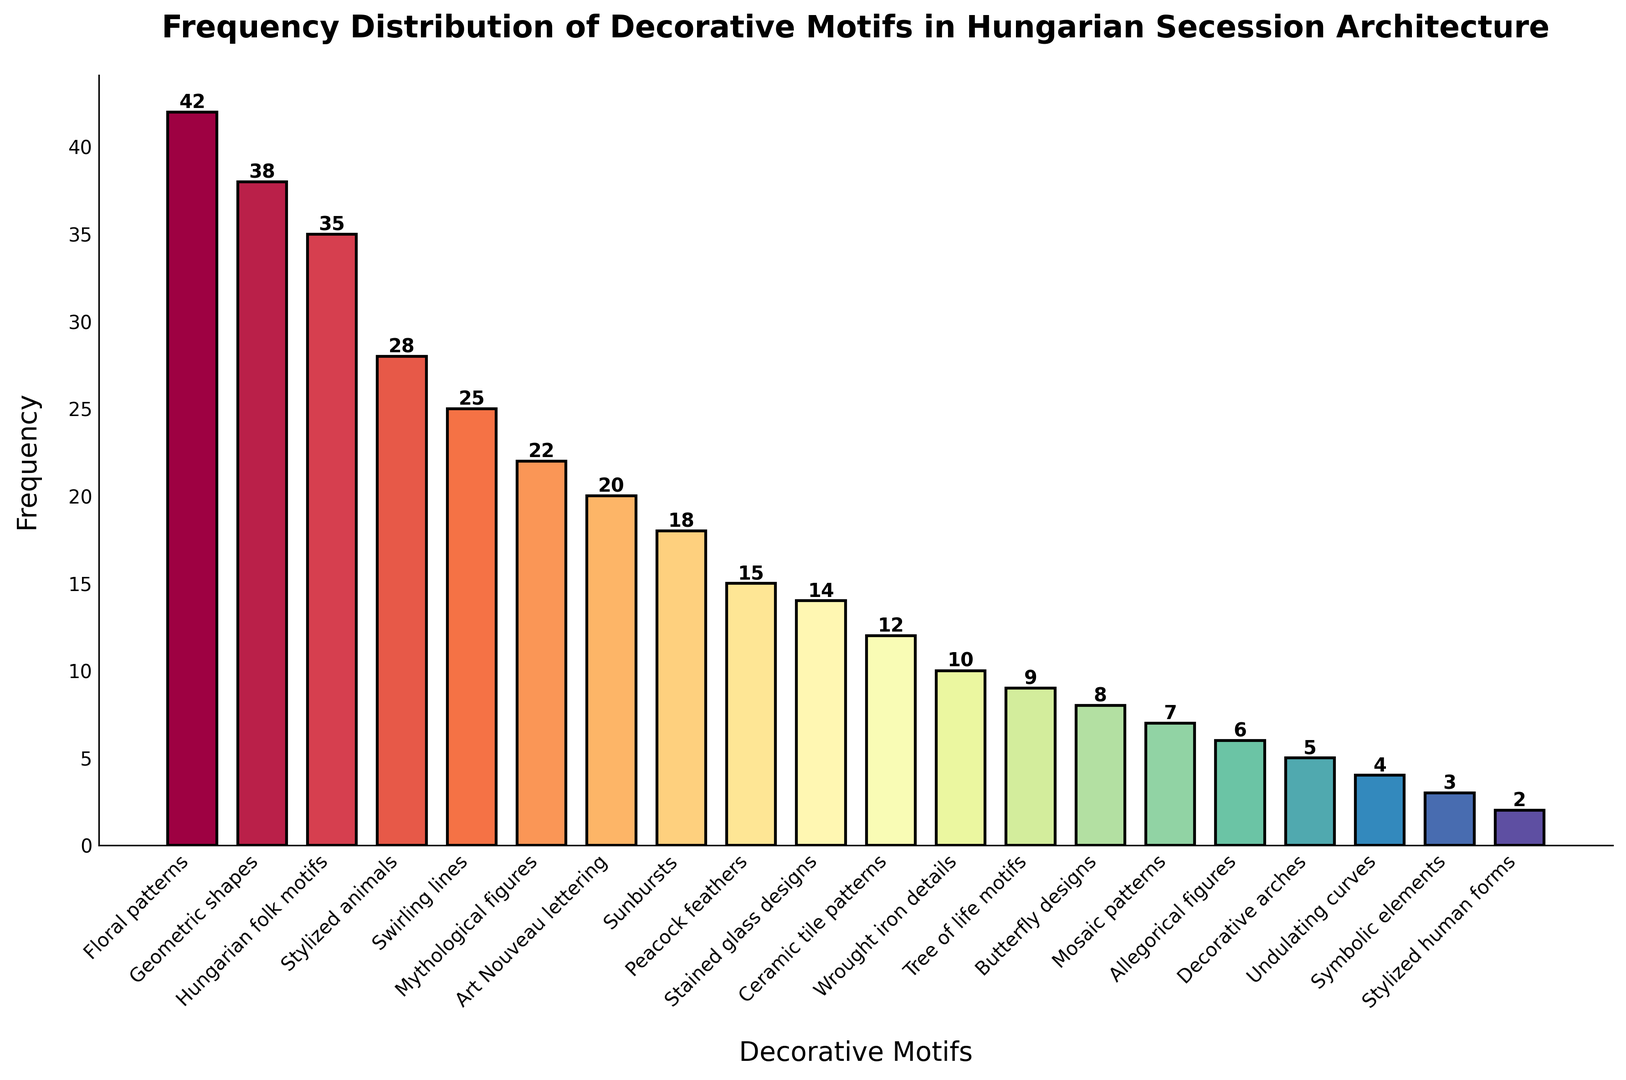Which motif appears most frequently? By examining the height of the bars in the plot, we observe that the tallest bar corresponds to "Floral patterns," indicating it appears most frequently.
Answer: Floral patterns Which two motifs have the highest frequencies, and what is their combined frequency? The plot shows that "Floral patterns" and "Geometric shapes" have the highest frequencies, with 42 and 38 respectively. The combined frequency is calculated by adding these two values: 42 + 38 = 80.
Answer: 80 Which motif has the lowest frequency? The shortest bar in the plot corresponds to "Stylized human forms," indicating it has the lowest frequency.
Answer: Stylized human forms Which motif appears more frequently: "Hungarian folk motifs" or "Sunbursts"? By comparing the heights of the bars, we see that "Hungarian folk motifs" has a frequency of 35, which is higher than "Sunbursts," which has a frequency of 18.
Answer: Hungarian folk motifs What is the average frequency of the three least frequent motifs? The three least frequent motifs are "Stylized human forms" (2), "Symbolic elements" (3), and "Undulating curves" (4). The average is calculated by summing their frequencies (2 + 3 + 4 = 9) and dividing by 3: 9 / 3 = 3.
Answer: 3 How many motifs have a frequency greater than 20? By counting the bars with heights above 20 in the plot, we find that there are five motifs with frequencies greater than 20: "Floral patterns," "Geometric shapes," "Hungarian folk motifs," "Stylized animals," and "Swirling lines."
Answer: 5 Which motif is represented with the darkest color in the bar plot, and what is its frequency? The darkest colors usually correspond to the beginning or end of the color spectrum used. In this plot, "Floral patterns" has the darkest color and a frequency of 42.
Answer: 42 Is "Mosaic patterns" more frequent than "Allegorical figures"? By comparing the heights of the bars for "Mosaic patterns" (7) and "Allegorical figures" (6), we see that "Mosaic patterns" is slightly more frequent.
Answer: Yes How much more frequent are "Wrought iron details" compared to "Tree of life motifs"? The frequency of "Wrought iron details" is 10, and the frequency of "Tree of life motifs" is 9. The difference is calculated as 10 - 9 = 1.
Answer: 1 Which motif has a frequency that is half of the most frequent motif? The most frequent motif is "Floral patterns" with a frequency of 42. Half of this frequency is 42 / 2 = 21. "Mythological figures" with a frequency of 22 is the closest motif to this value.
Answer: Mythological figures 